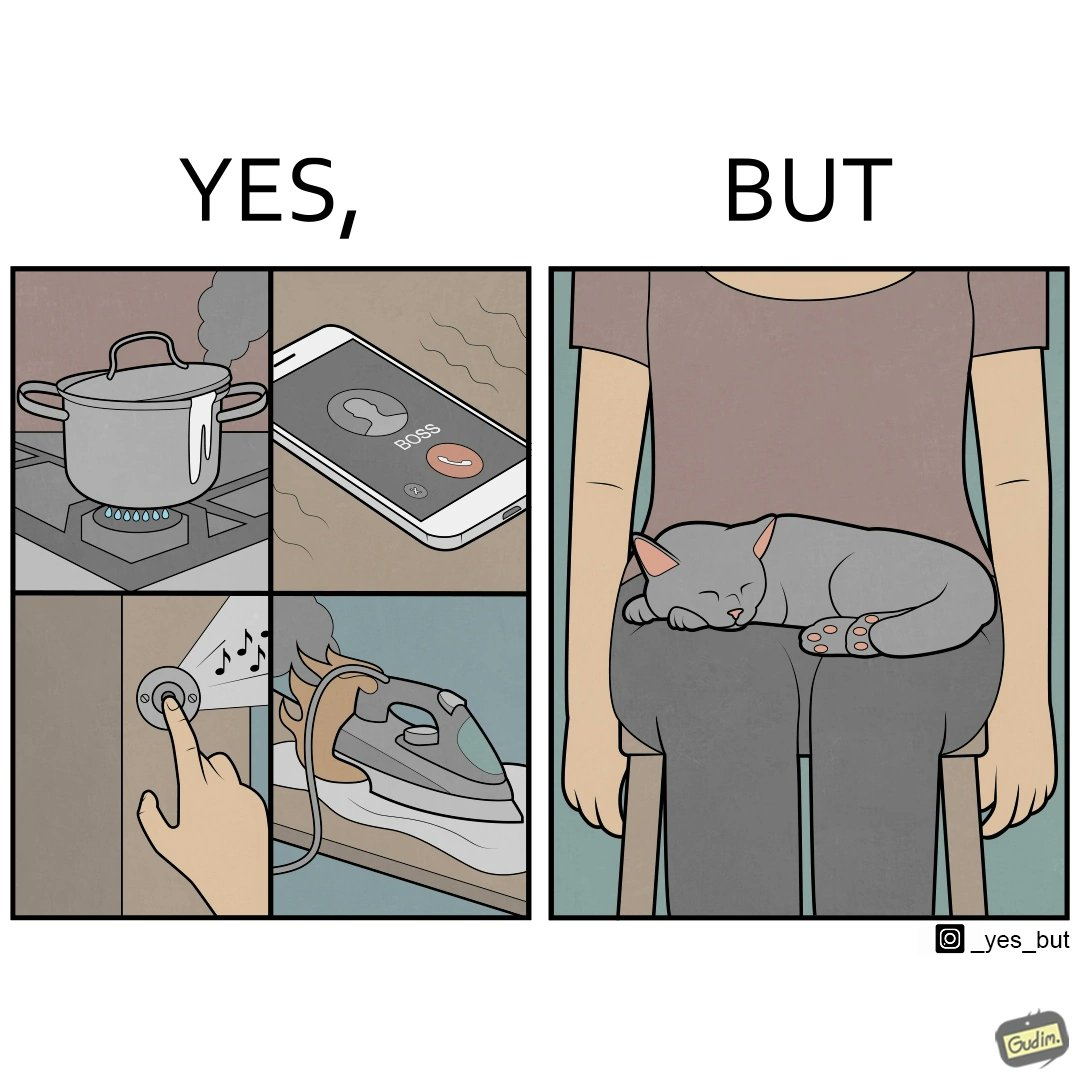What is shown in this image? the irony in this image is that people ignore all the chaos around them and get distracted by a cat. 